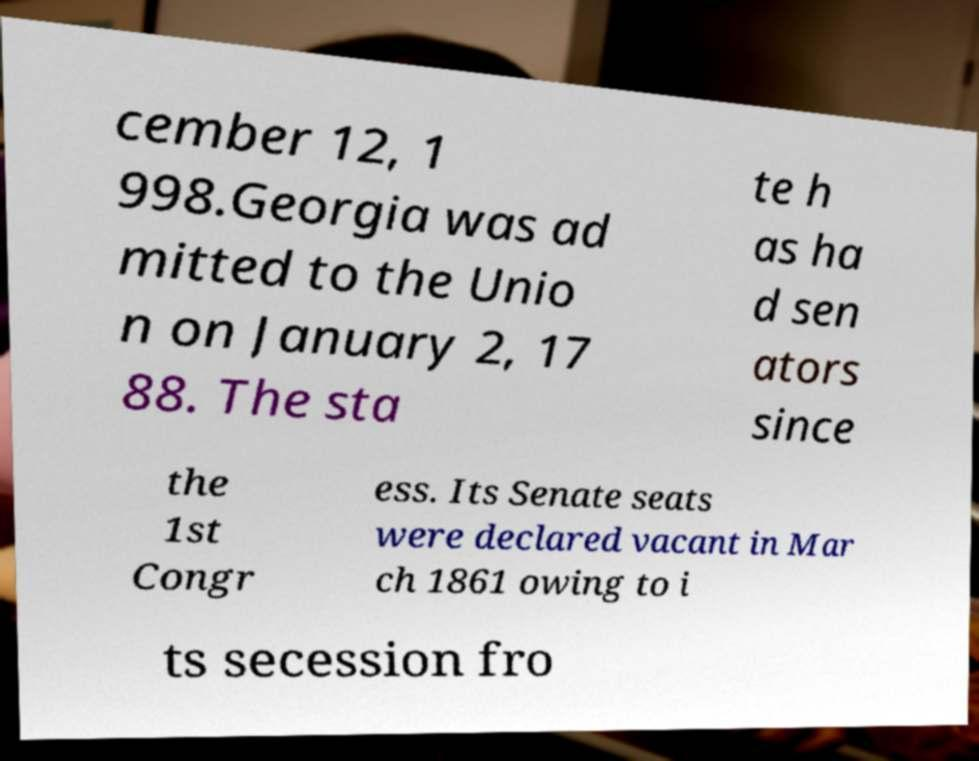For documentation purposes, I need the text within this image transcribed. Could you provide that? cember 12, 1 998.Georgia was ad mitted to the Unio n on January 2, 17 88. The sta te h as ha d sen ators since the 1st Congr ess. Its Senate seats were declared vacant in Mar ch 1861 owing to i ts secession fro 